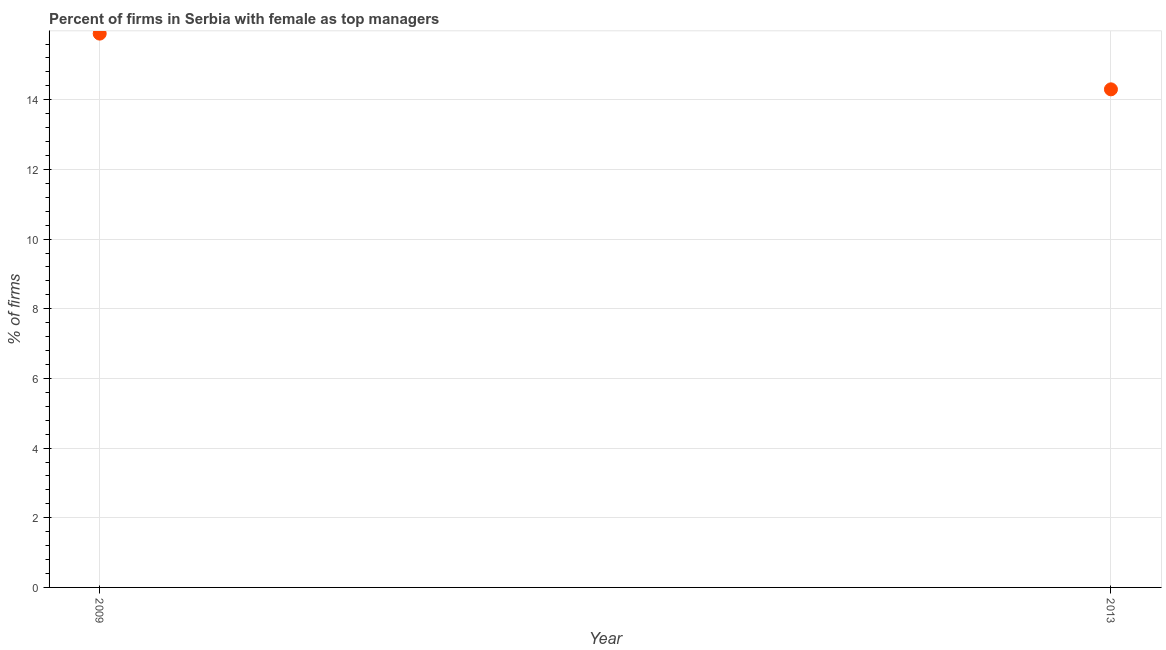Across all years, what is the maximum percentage of firms with female as top manager?
Make the answer very short. 15.9. Across all years, what is the minimum percentage of firms with female as top manager?
Offer a terse response. 14.3. In which year was the percentage of firms with female as top manager maximum?
Your answer should be compact. 2009. What is the sum of the percentage of firms with female as top manager?
Offer a very short reply. 30.2. What is the difference between the percentage of firms with female as top manager in 2009 and 2013?
Your answer should be compact. 1.6. What is the average percentage of firms with female as top manager per year?
Make the answer very short. 15.1. What is the median percentage of firms with female as top manager?
Provide a succinct answer. 15.1. Do a majority of the years between 2009 and 2013 (inclusive) have percentage of firms with female as top manager greater than 11.6 %?
Make the answer very short. Yes. What is the ratio of the percentage of firms with female as top manager in 2009 to that in 2013?
Offer a terse response. 1.11. How many dotlines are there?
Your answer should be compact. 1. What is the difference between two consecutive major ticks on the Y-axis?
Your response must be concise. 2. Does the graph contain any zero values?
Your response must be concise. No. What is the title of the graph?
Provide a short and direct response. Percent of firms in Serbia with female as top managers. What is the label or title of the X-axis?
Offer a very short reply. Year. What is the label or title of the Y-axis?
Your response must be concise. % of firms. What is the % of firms in 2013?
Your answer should be very brief. 14.3. What is the difference between the % of firms in 2009 and 2013?
Offer a terse response. 1.6. What is the ratio of the % of firms in 2009 to that in 2013?
Offer a very short reply. 1.11. 